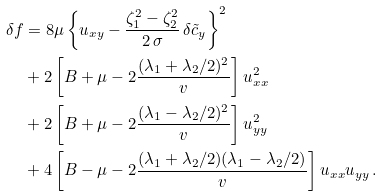Convert formula to latex. <formula><loc_0><loc_0><loc_500><loc_500>\delta f & = 8 \mu \left \{ u _ { x y } - \frac { \zeta _ { 1 } ^ { 2 } - \zeta _ { 2 } ^ { 2 } } { 2 \, \sigma } \, \delta \tilde { c } _ { y } \right \} ^ { 2 } \\ & + 2 \left [ B + \mu - 2 \frac { ( \lambda _ { 1 } + \lambda _ { 2 } / 2 ) ^ { 2 } } { v } \right ] u _ { x x } ^ { 2 } \\ & + 2 \left [ B + \mu - 2 \frac { ( \lambda _ { 1 } - \lambda _ { 2 } / 2 ) ^ { 2 } } { v } \right ] u _ { y y } ^ { 2 } \\ & + 4 \left [ B - \mu - 2 \frac { ( \lambda _ { 1 } + \lambda _ { 2 } / 2 ) ( \lambda _ { 1 } - \lambda _ { 2 } / 2 ) } { v } \right ] u _ { x x } u _ { y y } \, .</formula> 